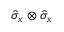<formula> <loc_0><loc_0><loc_500><loc_500>\hat { \sigma } _ { x } \otimes \hat { \sigma } _ { x }</formula> 